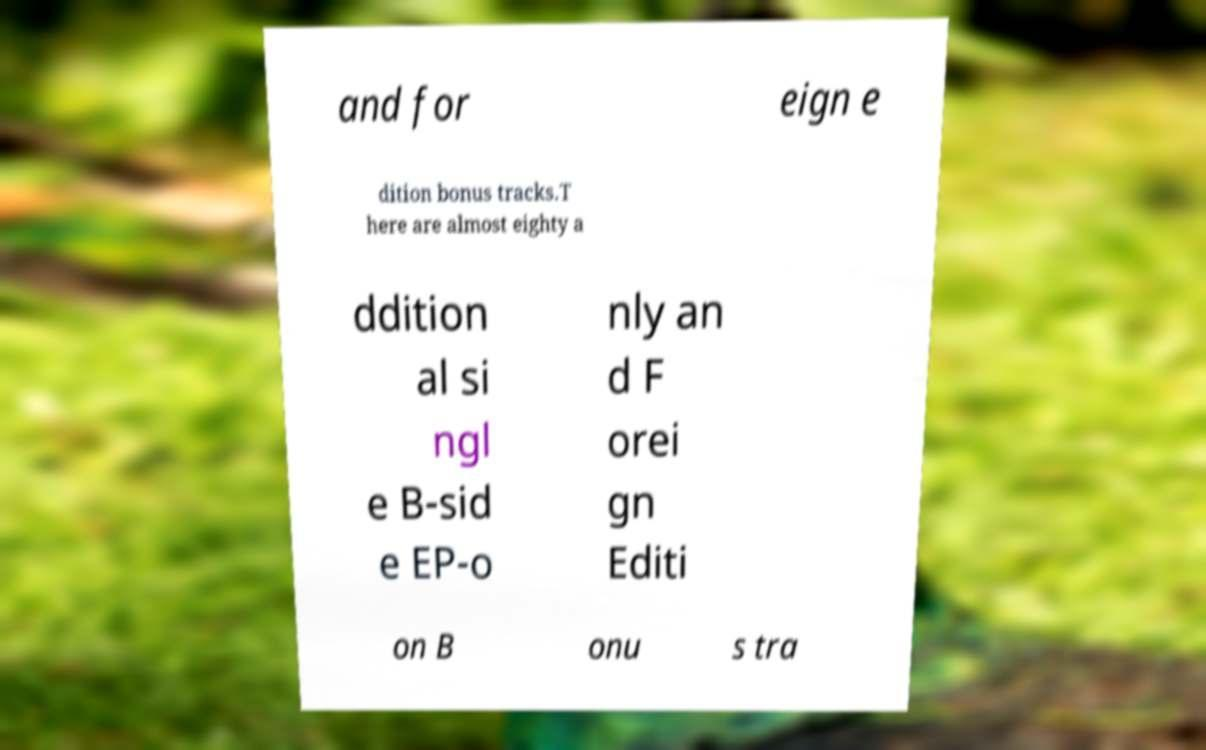Could you extract and type out the text from this image? and for eign e dition bonus tracks.T here are almost eighty a ddition al si ngl e B-sid e EP-o nly an d F orei gn Editi on B onu s tra 